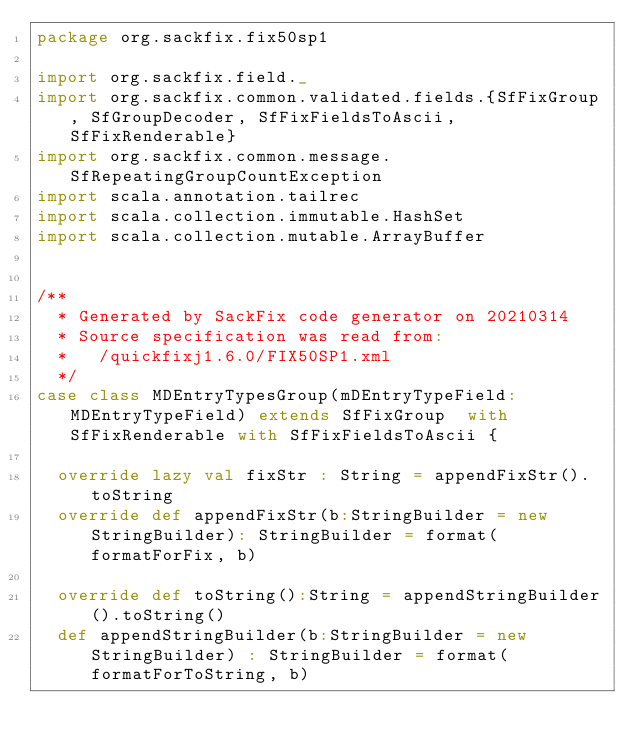<code> <loc_0><loc_0><loc_500><loc_500><_Scala_>package org.sackfix.fix50sp1

import org.sackfix.field._
import org.sackfix.common.validated.fields.{SfFixGroup, SfGroupDecoder, SfFixFieldsToAscii, SfFixRenderable}
import org.sackfix.common.message.SfRepeatingGroupCountException
import scala.annotation.tailrec
import scala.collection.immutable.HashSet
import scala.collection.mutable.ArrayBuffer


/**
  * Generated by SackFix code generator on 20210314
  * Source specification was read from:
  *   /quickfixj1.6.0/FIX50SP1.xml
  */
case class MDEntryTypesGroup(mDEntryTypeField:MDEntryTypeField) extends SfFixGroup  with SfFixRenderable with SfFixFieldsToAscii {

  override lazy val fixStr : String = appendFixStr().toString
  override def appendFixStr(b:StringBuilder = new StringBuilder): StringBuilder = format(formatForFix, b)

  override def toString():String = appendStringBuilder().toString()
  def appendStringBuilder(b:StringBuilder = new StringBuilder) : StringBuilder = format(formatForToString, b)
</code> 